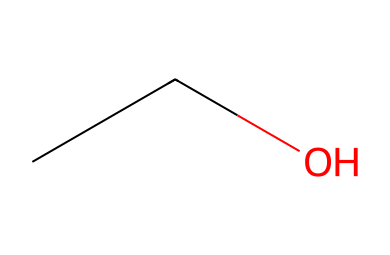What is the name of this chemical? The SMILES representation "CCO" corresponds to ethanol, a simple alcohol with an ethyl group (CC) and a hydroxyl group (O).
Answer: ethanol How many carbon atoms are in ethanol? The SMILES "CCO" indicates the presence of two carbon atoms (C) as shown by the two 'C' in the structure before the 'O'.
Answer: 2 What functional group is present in ethanol? In the SMILES "CCO", the 'O' represents a hydroxyl functional group (-OH), which classifies ethanol as an alcohol.
Answer: hydroxyl What is the total number of hydrogen atoms in ethanol? The structure "CCO" includes two carbon atoms, which typically bond with five hydrogen atoms (C2H5), in addition to the hydroxyl group that has one hydrogen (OH), resulting in a total of six hydrogen atoms.
Answer: 6 Is ethanol an aliphatic compound? Ethanol is classified as an aliphatic compound due to its straight-chain structure consisting of carbon and hydrogen atoms, without any cyclic rings.
Answer: yes What is the molecular formula of ethanol? The SMILES "CCO" can be translated into the molecular formula by counting the atoms: two carbons (C), six hydrogens (H), and one oxygen (O) results in C2H6O.
Answer: C2H6O 